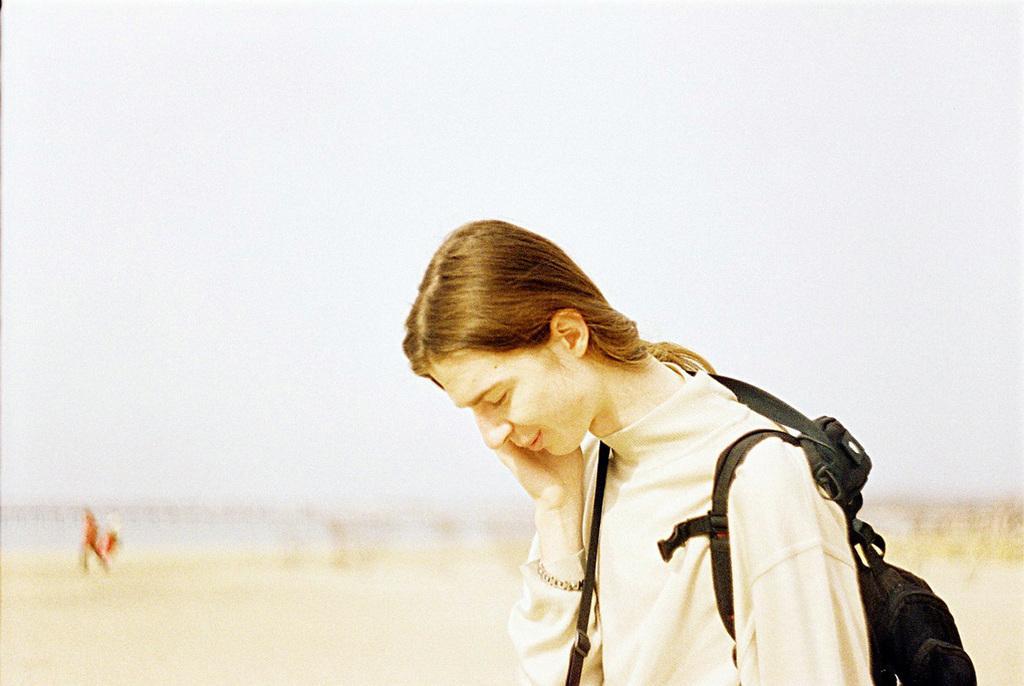Describe this image in one or two sentences. In this image we can see a person wearing a bag. In the background it is looking blur. 